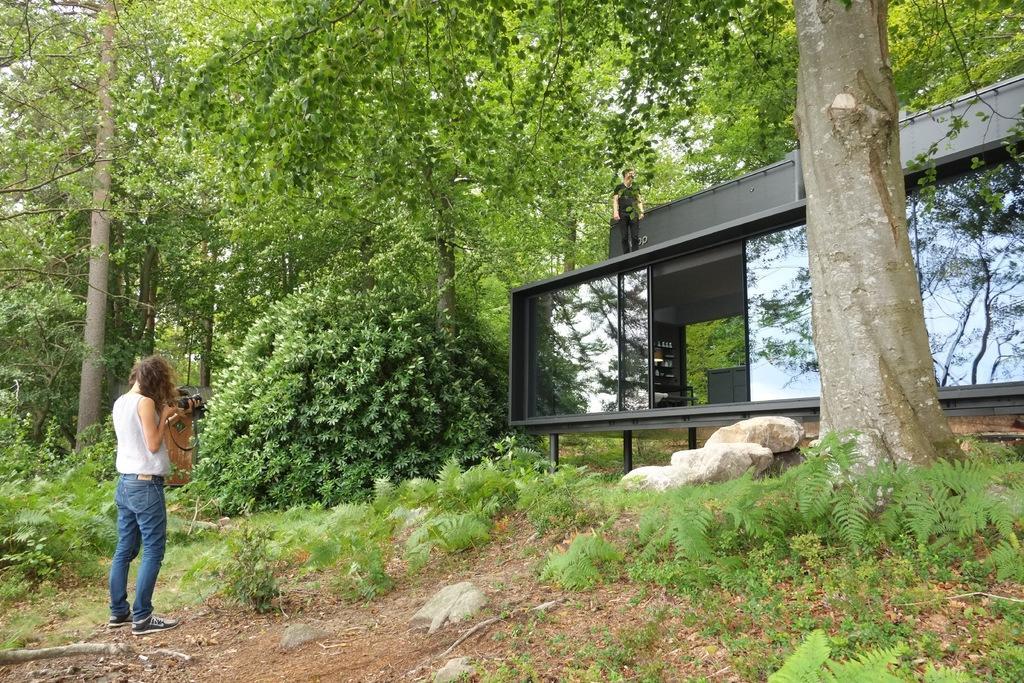Could you give a brief overview of what you see in this image? In this image we can see a store and few objects are placed in it. There are two persons in the image. A lady is holding an object in her hand at the left side of the image. There is a reflection of trees and a sky on the glasses. There many trees and plants in the image. 